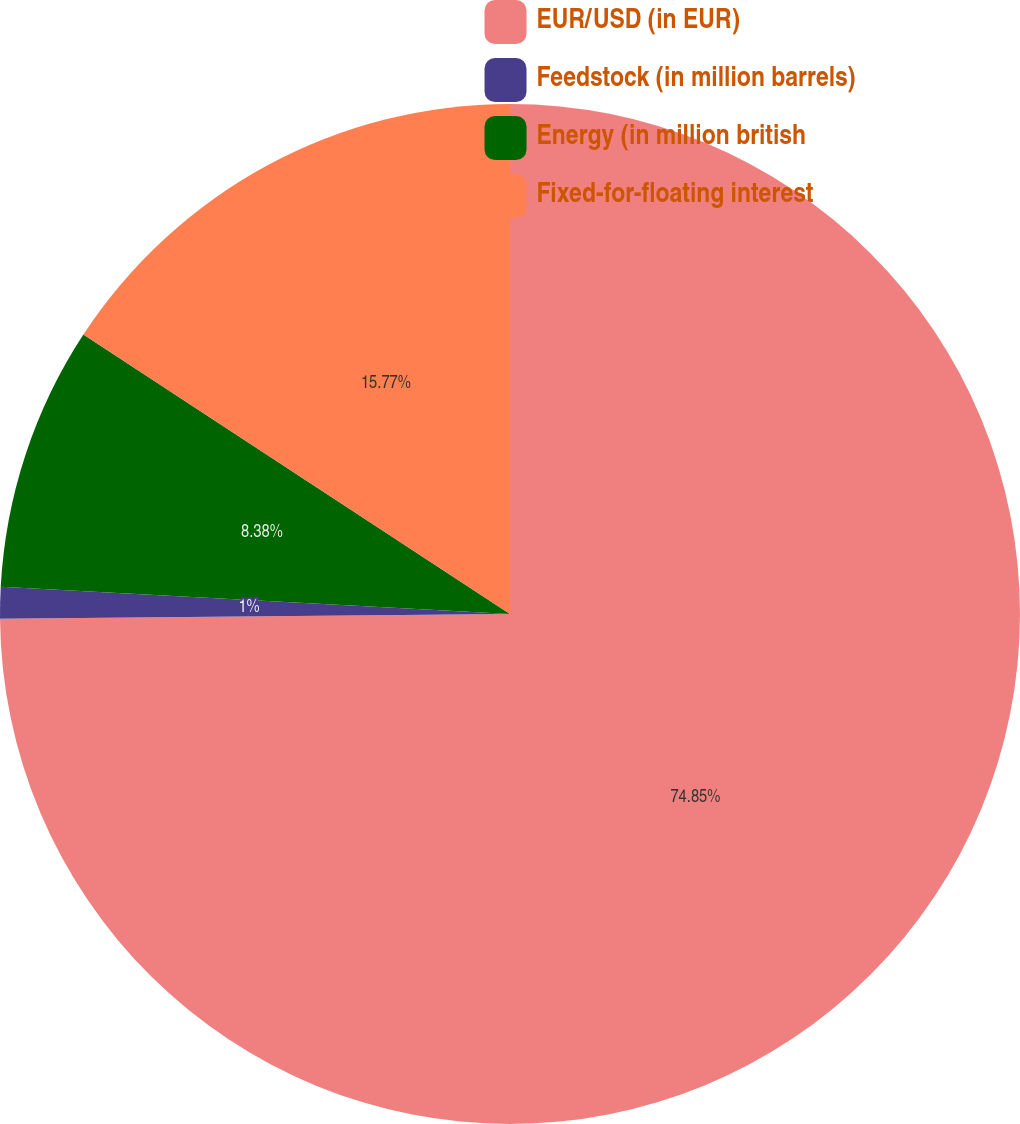Convert chart to OTSL. <chart><loc_0><loc_0><loc_500><loc_500><pie_chart><fcel>EUR/USD (in EUR)<fcel>Feedstock (in million barrels)<fcel>Energy (in million british<fcel>Fixed-for-floating interest<nl><fcel>74.85%<fcel>1.0%<fcel>8.38%<fcel>15.77%<nl></chart> 